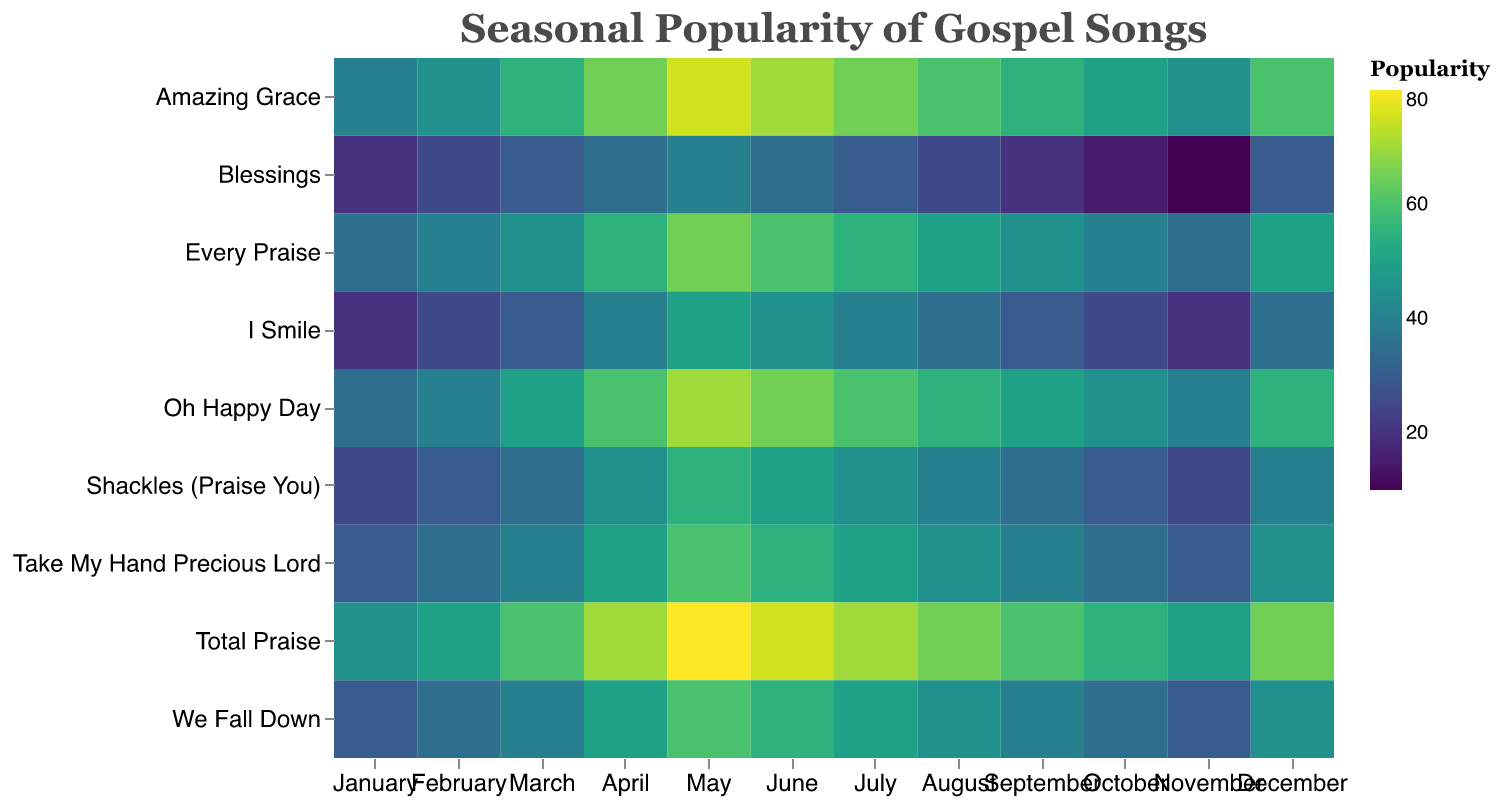What is the most popular song in May? In May, the song with the highest value will indicate the most popular song. From the data, "Total Praise" has a value of 80.
Answer: Total Praise How does the popularity of "Amazing Grace" change across the months? Look at the values for "Amazing Grace" over each month and describe the trend. It starts at 40 in January, increases steadily, peaks at 75 in May, and then generally decreases towards 60 in December.
Answer: Increases until May, then decreases Which month has the lowest popularity for "Blessings"? Identify the month with the lowest value in the "Blessings" row. The value of "Blessings" in November is 10, which is the lowest.
Answer: November Compare the popularity of "Shackles (Praise You)" in January and July. Compare the values for "Shackles (Praise You)" in the respective months. January has a value of 25, while July has a value of 45.
Answer: Higher in July What's the average popularity of "I Smile" in the first quarter? Sum the values of "I Smile" for January, February, and March and then divide by 3. (20 + 25 + 30) / 3 = 25
Answer: 25 Which song has the highest peak popularity, and in which month does it occur? Identify the highest single value in the data and its corresponding song and month. "Total Praise" has a value of 80 in May.
Answer: Total Praise, May How does the popularity of "We Fall Down" in December compare to its popularity in June? Compare the values for "We Fall Down" in December (45) and June (55).
Answer: Lower in December Find the sum of the popularity values for "Oh Happy Day" across all months. Sum the popularity values for "Oh Happy Day" from January to December: 35 + 40 + 50 + 60 + 70 + 65 + 60 + 55 + 50 + 45 + 40 + 55 = 625
Answer: 625 Which month sees a decline in popularity for all the songs compared to the previous month? Compare the values for each month with the preceding month and identify the month where all the values are lower. There is no month in which all values decline compared to the previous month.
Answer: None Is there a month where "Amazing Grace" and "Total Praise" have the same popularity? Look for matching values in the "Amazing Grace" and "Total Praise" rows. The values match at 60 in both "Amazing Grace" and "Total Praise" in September.
Answer: September 